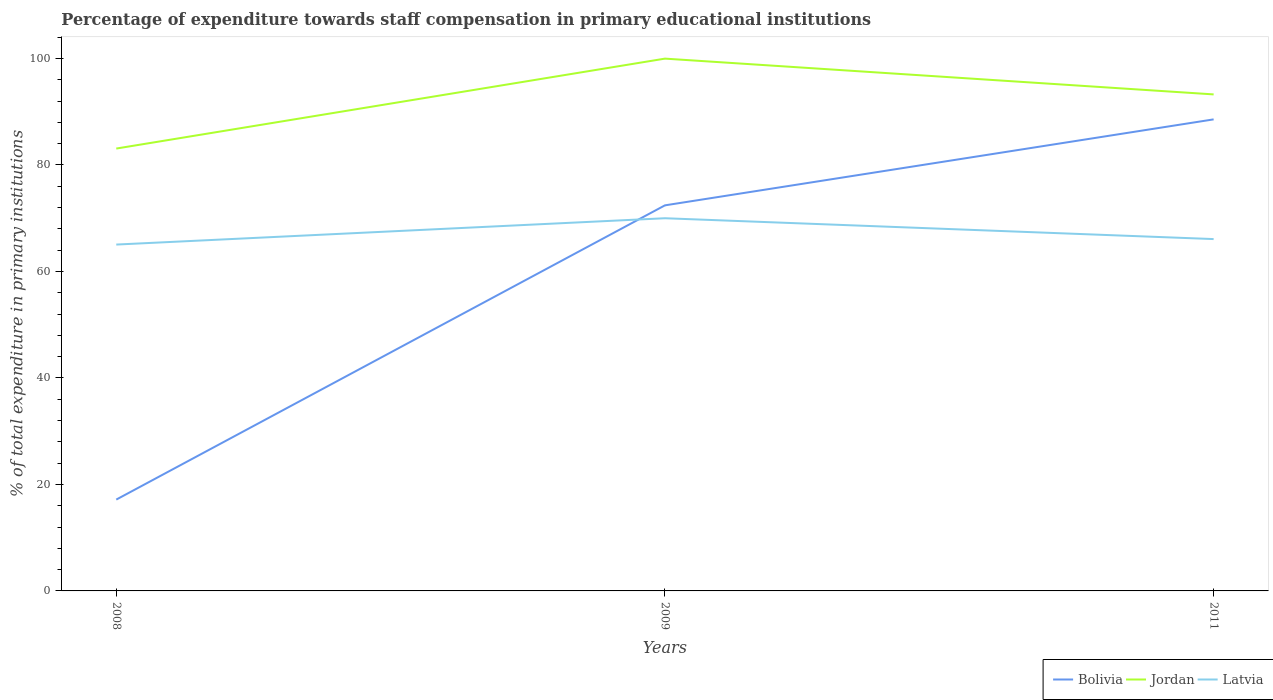Does the line corresponding to Bolivia intersect with the line corresponding to Latvia?
Provide a short and direct response. Yes. Is the number of lines equal to the number of legend labels?
Your answer should be very brief. Yes. Across all years, what is the maximum percentage of expenditure towards staff compensation in Jordan?
Offer a very short reply. 83.08. What is the total percentage of expenditure towards staff compensation in Jordan in the graph?
Your response must be concise. 6.72. What is the difference between the highest and the second highest percentage of expenditure towards staff compensation in Jordan?
Keep it short and to the point. 16.89. Is the percentage of expenditure towards staff compensation in Jordan strictly greater than the percentage of expenditure towards staff compensation in Bolivia over the years?
Your answer should be very brief. No. How many lines are there?
Give a very brief answer. 3. Are the values on the major ticks of Y-axis written in scientific E-notation?
Offer a terse response. No. Where does the legend appear in the graph?
Offer a terse response. Bottom right. How many legend labels are there?
Make the answer very short. 3. What is the title of the graph?
Your response must be concise. Percentage of expenditure towards staff compensation in primary educational institutions. What is the label or title of the X-axis?
Ensure brevity in your answer.  Years. What is the label or title of the Y-axis?
Offer a terse response. % of total expenditure in primary institutions. What is the % of total expenditure in primary institutions of Bolivia in 2008?
Your answer should be compact. 17.15. What is the % of total expenditure in primary institutions in Jordan in 2008?
Offer a terse response. 83.08. What is the % of total expenditure in primary institutions in Latvia in 2008?
Your response must be concise. 65.05. What is the % of total expenditure in primary institutions in Bolivia in 2009?
Provide a succinct answer. 72.41. What is the % of total expenditure in primary institutions in Jordan in 2009?
Your answer should be very brief. 99.96. What is the % of total expenditure in primary institutions in Latvia in 2009?
Your answer should be very brief. 69.99. What is the % of total expenditure in primary institutions of Bolivia in 2011?
Provide a short and direct response. 88.55. What is the % of total expenditure in primary institutions in Jordan in 2011?
Keep it short and to the point. 93.24. What is the % of total expenditure in primary institutions in Latvia in 2011?
Ensure brevity in your answer.  66.07. Across all years, what is the maximum % of total expenditure in primary institutions in Bolivia?
Your response must be concise. 88.55. Across all years, what is the maximum % of total expenditure in primary institutions of Jordan?
Your answer should be compact. 99.96. Across all years, what is the maximum % of total expenditure in primary institutions in Latvia?
Keep it short and to the point. 69.99. Across all years, what is the minimum % of total expenditure in primary institutions of Bolivia?
Provide a succinct answer. 17.15. Across all years, what is the minimum % of total expenditure in primary institutions of Jordan?
Your answer should be compact. 83.08. Across all years, what is the minimum % of total expenditure in primary institutions of Latvia?
Your answer should be compact. 65.05. What is the total % of total expenditure in primary institutions in Bolivia in the graph?
Your answer should be very brief. 178.12. What is the total % of total expenditure in primary institutions of Jordan in the graph?
Offer a very short reply. 276.28. What is the total % of total expenditure in primary institutions in Latvia in the graph?
Offer a very short reply. 201.11. What is the difference between the % of total expenditure in primary institutions of Bolivia in 2008 and that in 2009?
Keep it short and to the point. -55.26. What is the difference between the % of total expenditure in primary institutions in Jordan in 2008 and that in 2009?
Give a very brief answer. -16.89. What is the difference between the % of total expenditure in primary institutions in Latvia in 2008 and that in 2009?
Provide a succinct answer. -4.94. What is the difference between the % of total expenditure in primary institutions in Bolivia in 2008 and that in 2011?
Your response must be concise. -71.4. What is the difference between the % of total expenditure in primary institutions in Jordan in 2008 and that in 2011?
Provide a succinct answer. -10.17. What is the difference between the % of total expenditure in primary institutions of Latvia in 2008 and that in 2011?
Keep it short and to the point. -1.03. What is the difference between the % of total expenditure in primary institutions in Bolivia in 2009 and that in 2011?
Provide a short and direct response. -16.14. What is the difference between the % of total expenditure in primary institutions in Jordan in 2009 and that in 2011?
Give a very brief answer. 6.72. What is the difference between the % of total expenditure in primary institutions of Latvia in 2009 and that in 2011?
Provide a short and direct response. 3.91. What is the difference between the % of total expenditure in primary institutions in Bolivia in 2008 and the % of total expenditure in primary institutions in Jordan in 2009?
Offer a very short reply. -82.81. What is the difference between the % of total expenditure in primary institutions of Bolivia in 2008 and the % of total expenditure in primary institutions of Latvia in 2009?
Give a very brief answer. -52.84. What is the difference between the % of total expenditure in primary institutions in Jordan in 2008 and the % of total expenditure in primary institutions in Latvia in 2009?
Offer a very short reply. 13.09. What is the difference between the % of total expenditure in primary institutions of Bolivia in 2008 and the % of total expenditure in primary institutions of Jordan in 2011?
Ensure brevity in your answer.  -76.09. What is the difference between the % of total expenditure in primary institutions of Bolivia in 2008 and the % of total expenditure in primary institutions of Latvia in 2011?
Your response must be concise. -48.92. What is the difference between the % of total expenditure in primary institutions of Jordan in 2008 and the % of total expenditure in primary institutions of Latvia in 2011?
Offer a very short reply. 17. What is the difference between the % of total expenditure in primary institutions in Bolivia in 2009 and the % of total expenditure in primary institutions in Jordan in 2011?
Offer a very short reply. -20.83. What is the difference between the % of total expenditure in primary institutions of Bolivia in 2009 and the % of total expenditure in primary institutions of Latvia in 2011?
Ensure brevity in your answer.  6.34. What is the difference between the % of total expenditure in primary institutions in Jordan in 2009 and the % of total expenditure in primary institutions in Latvia in 2011?
Your response must be concise. 33.89. What is the average % of total expenditure in primary institutions in Bolivia per year?
Offer a terse response. 59.37. What is the average % of total expenditure in primary institutions in Jordan per year?
Make the answer very short. 92.09. What is the average % of total expenditure in primary institutions of Latvia per year?
Offer a terse response. 67.04. In the year 2008, what is the difference between the % of total expenditure in primary institutions of Bolivia and % of total expenditure in primary institutions of Jordan?
Ensure brevity in your answer.  -65.92. In the year 2008, what is the difference between the % of total expenditure in primary institutions of Bolivia and % of total expenditure in primary institutions of Latvia?
Provide a short and direct response. -47.89. In the year 2008, what is the difference between the % of total expenditure in primary institutions in Jordan and % of total expenditure in primary institutions in Latvia?
Your answer should be very brief. 18.03. In the year 2009, what is the difference between the % of total expenditure in primary institutions of Bolivia and % of total expenditure in primary institutions of Jordan?
Offer a terse response. -27.55. In the year 2009, what is the difference between the % of total expenditure in primary institutions in Bolivia and % of total expenditure in primary institutions in Latvia?
Keep it short and to the point. 2.42. In the year 2009, what is the difference between the % of total expenditure in primary institutions in Jordan and % of total expenditure in primary institutions in Latvia?
Keep it short and to the point. 29.97. In the year 2011, what is the difference between the % of total expenditure in primary institutions of Bolivia and % of total expenditure in primary institutions of Jordan?
Offer a terse response. -4.69. In the year 2011, what is the difference between the % of total expenditure in primary institutions of Bolivia and % of total expenditure in primary institutions of Latvia?
Provide a succinct answer. 22.48. In the year 2011, what is the difference between the % of total expenditure in primary institutions in Jordan and % of total expenditure in primary institutions in Latvia?
Offer a terse response. 27.17. What is the ratio of the % of total expenditure in primary institutions in Bolivia in 2008 to that in 2009?
Your response must be concise. 0.24. What is the ratio of the % of total expenditure in primary institutions of Jordan in 2008 to that in 2009?
Your response must be concise. 0.83. What is the ratio of the % of total expenditure in primary institutions in Latvia in 2008 to that in 2009?
Provide a short and direct response. 0.93. What is the ratio of the % of total expenditure in primary institutions in Bolivia in 2008 to that in 2011?
Keep it short and to the point. 0.19. What is the ratio of the % of total expenditure in primary institutions in Jordan in 2008 to that in 2011?
Offer a terse response. 0.89. What is the ratio of the % of total expenditure in primary institutions of Latvia in 2008 to that in 2011?
Your answer should be compact. 0.98. What is the ratio of the % of total expenditure in primary institutions in Bolivia in 2009 to that in 2011?
Your response must be concise. 0.82. What is the ratio of the % of total expenditure in primary institutions of Jordan in 2009 to that in 2011?
Offer a very short reply. 1.07. What is the ratio of the % of total expenditure in primary institutions in Latvia in 2009 to that in 2011?
Your response must be concise. 1.06. What is the difference between the highest and the second highest % of total expenditure in primary institutions in Bolivia?
Your answer should be compact. 16.14. What is the difference between the highest and the second highest % of total expenditure in primary institutions in Jordan?
Your answer should be compact. 6.72. What is the difference between the highest and the second highest % of total expenditure in primary institutions of Latvia?
Provide a succinct answer. 3.91. What is the difference between the highest and the lowest % of total expenditure in primary institutions of Bolivia?
Give a very brief answer. 71.4. What is the difference between the highest and the lowest % of total expenditure in primary institutions of Jordan?
Give a very brief answer. 16.89. What is the difference between the highest and the lowest % of total expenditure in primary institutions of Latvia?
Offer a terse response. 4.94. 